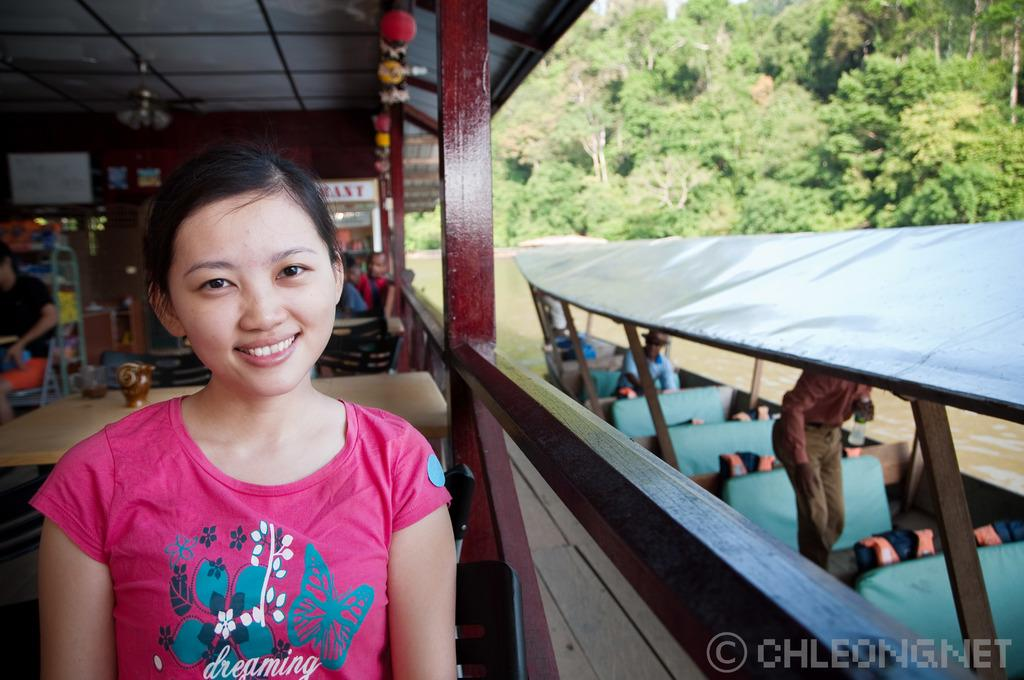What is happening in the image involving a group of people? There is a group of people in the image, and they are seated on chairs. Can you describe the woman in the image? There is a woman seated in the image. What else can be seen in the image besides the people? There is a boat on the side of the image, trees visible in the image, and water visible in the image. What type of bun is the woman holding in the image? There is no bun present in the image; the woman is seated without any visible objects in her hands. 